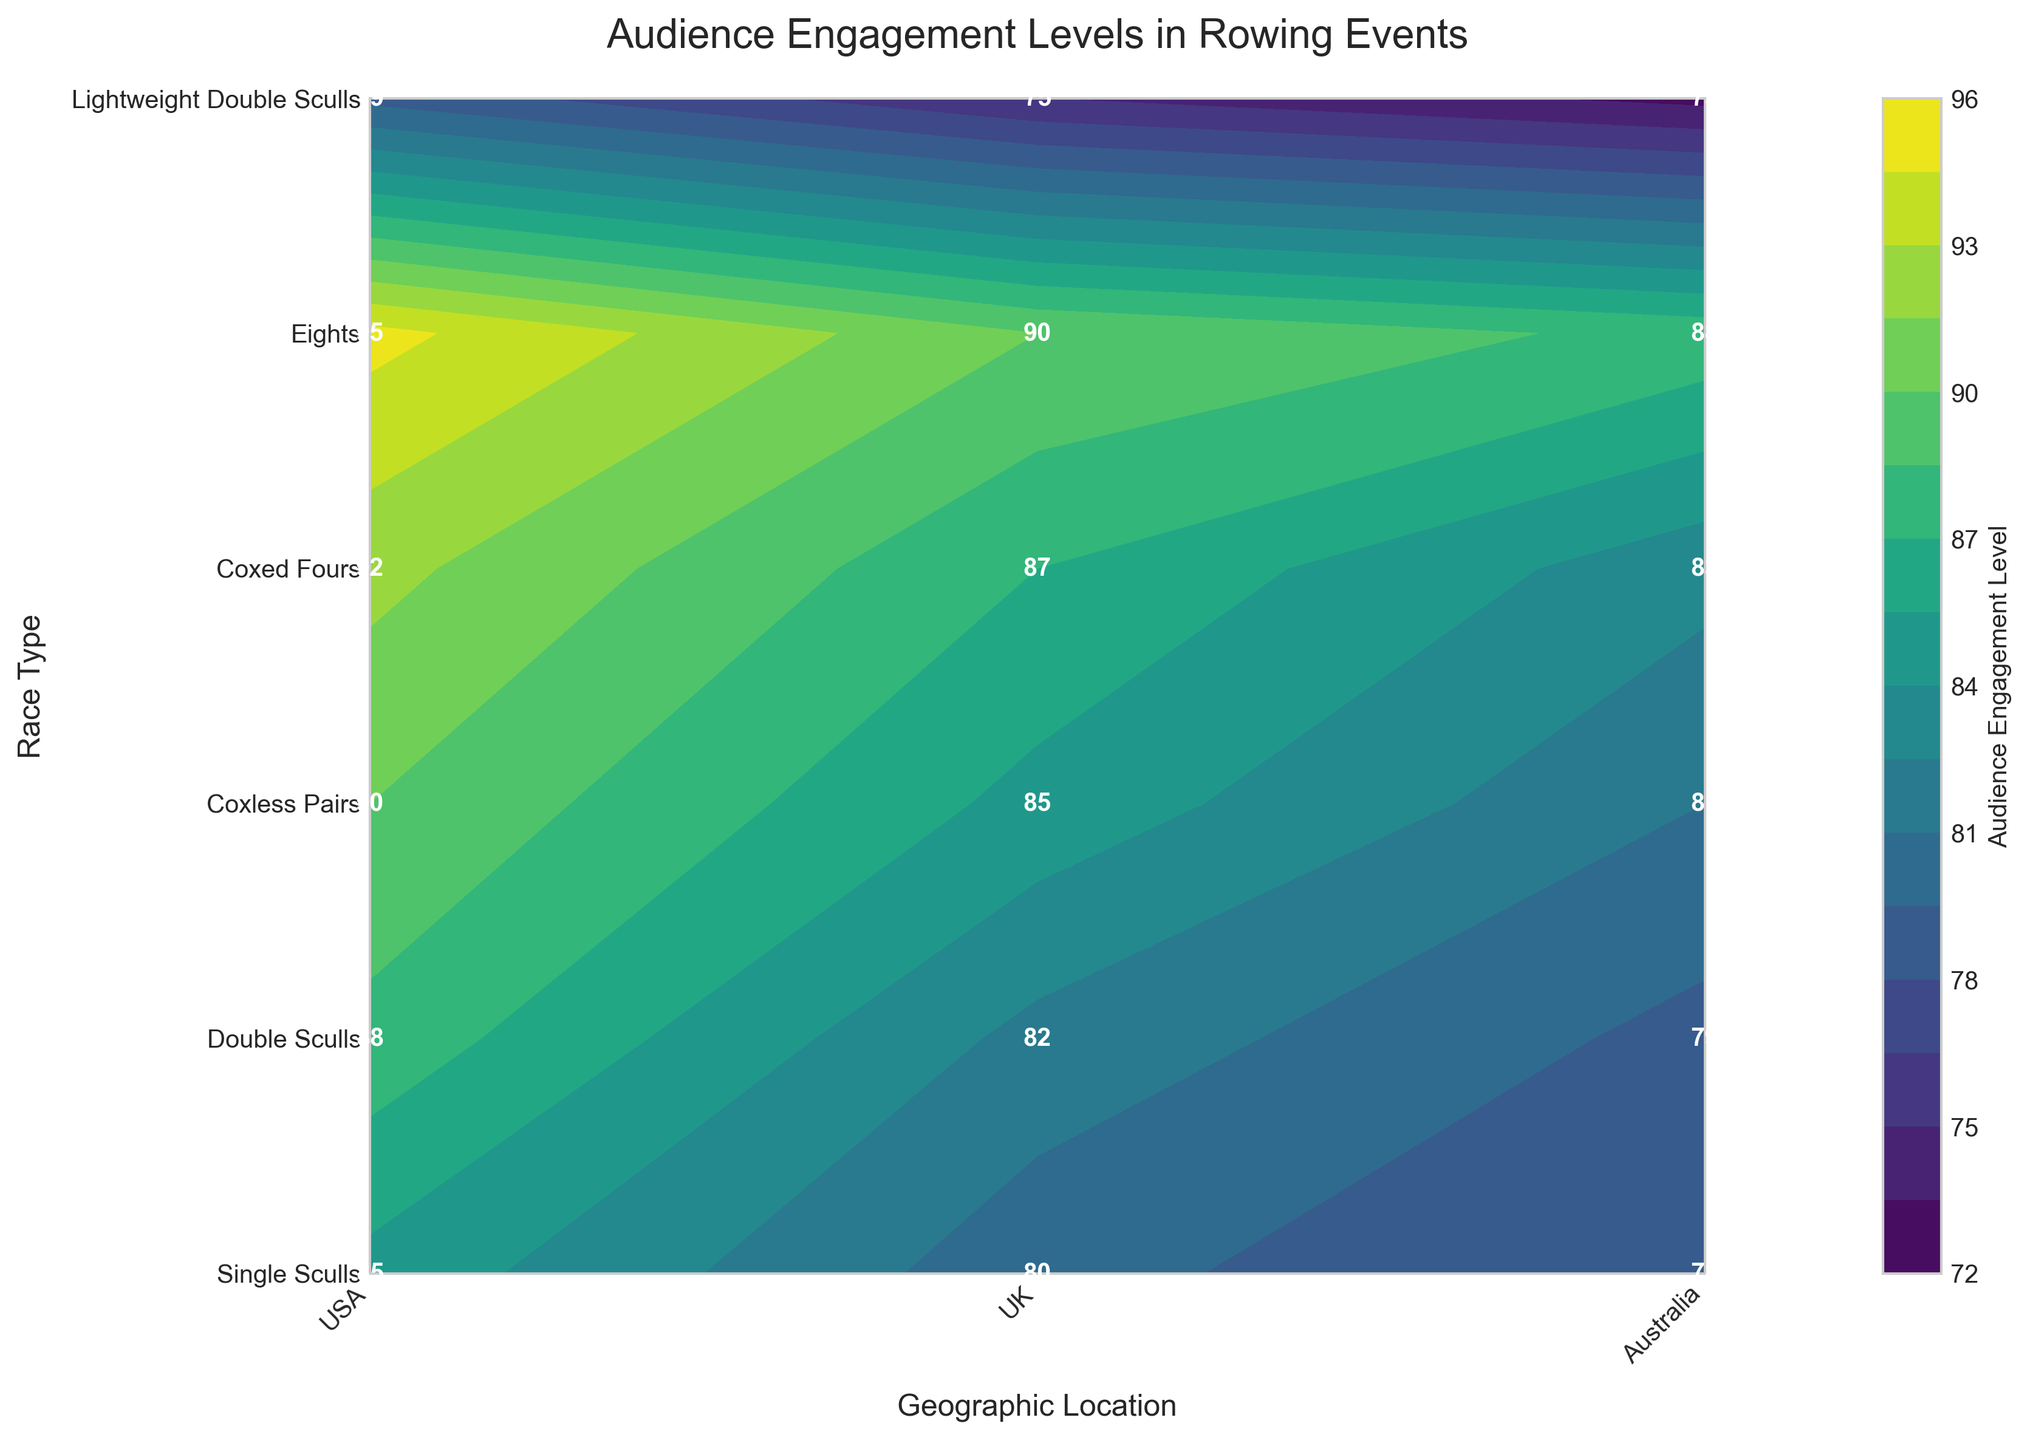What's the title of the plot? The title of the plot is written at the top of the figure in larger text. It helps to identify what the plot is about.
Answer: Audience Engagement Levels in Rowing Events Which country has the highest audience engagement level for Eights race type? To find this, look at the row corresponding to the Eights race type and compare the engagement levels for USA, UK, and Australia.
Answer: USA What are the geographic locations shown on the x-axis? The locations on the x-axis are labeled at the bottom of the plot and represent different geographic regions.
Answer: USA, UK, Australia How does audience engagement for Lightweight Double Sculls in the UK compare to the USA? Look at the engagement levels for Lightweight Double Sculls in both the UK and USA. Compare the numerical values displayed in the plot.
Answer: UK's is lower than USA's Which race type shows the highest audience engagement level in the UK? Look at the engagement levels for all race types in the UK column and identify the highest value.
Answer: Eights What's the average audience engagement level for Coxed Fours across all geographic locations? To calculate this, sum the engagement levels for Coxed Fours in USA, UK, and Australia and divide by the number of locations (3). Calculation: (92 + 87 + 83) / 3 = 87.33
Answer: 87.33 Between Double Sculls and Single Sculls, which race type has a higher average audience engagement level for the USA? Calculate the average engagement level for each race type in the USA: Single Sculls (85), Double Sculls (88). Compare these two averages: 88 > 85.
Answer: Double Sculls What is the contrast in audience engagement level between the highest and lowest race types in the Australian context? Identify the highest and lowest engagement levels for any race type in Australia (88 for Eights, 73 for Lightweight Double Sculls). Calculate the difference: 88 - 73 = 15.
Answer: 15 How does audience engagement for Single Sculls in the UK compare to Coxless Pairs in the USA? Look at the engagement levels for Single Sculls in the UK (80) and Coxless Pairs in the USA (90). Compare these values to find that Coxless Pairs in the USA is higher.
Answer: Coxless Pairs in the USA is higher Which race type in the plot has the lowest audience engagement in any location? Scan through all labeled engagement levels in the plot. Identify that Lightweight Double Sculls in Australia has the lowest engagement level (73).
Answer: Lightweight Double Sculls in Australia 